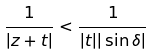<formula> <loc_0><loc_0><loc_500><loc_500>\frac { 1 } { | z + t | } < \frac { 1 } { | t | | \sin \delta | }</formula> 